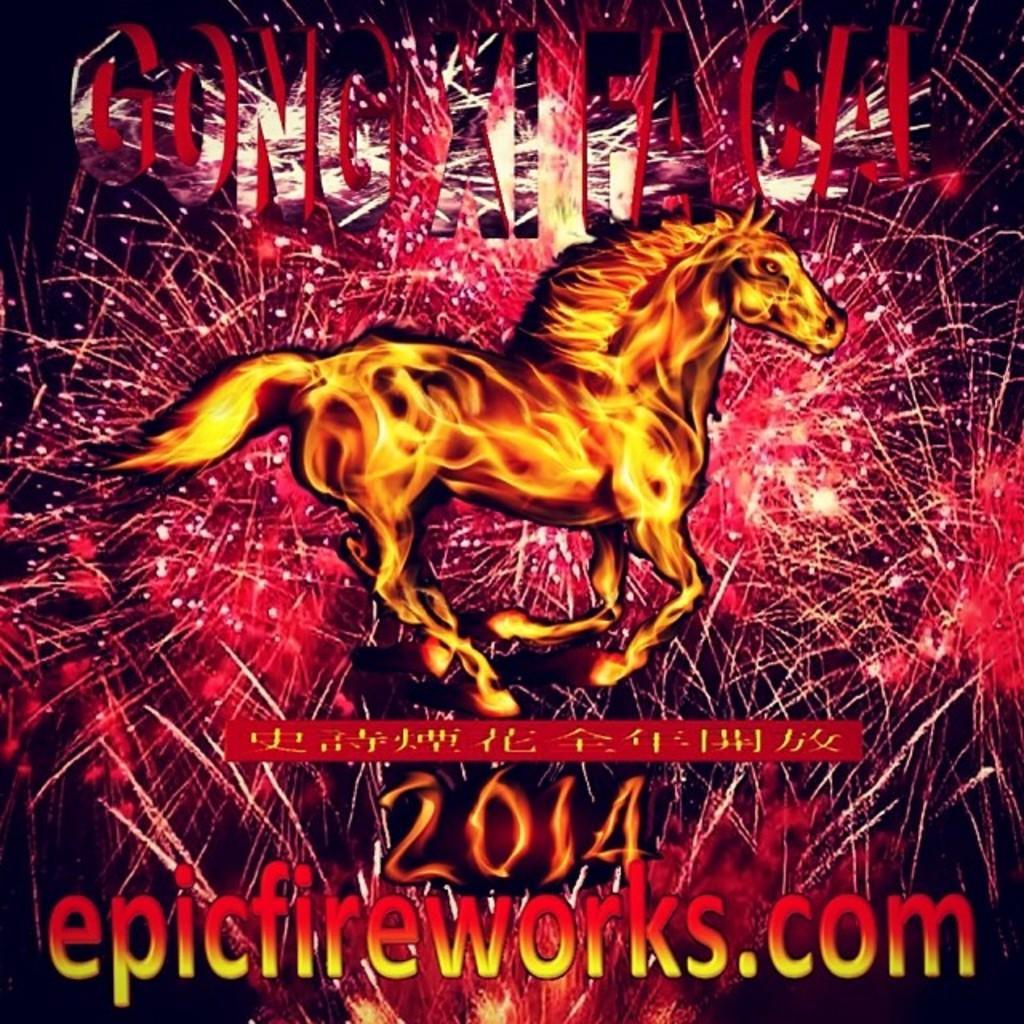Can you describe this image briefly? This is a poster. We can see a horse on this poster. There is a watermark. 